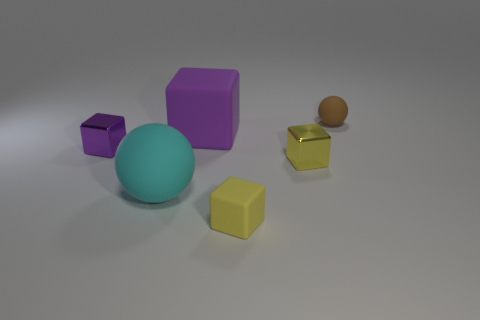There is a big purple object; what shape is it?
Keep it short and to the point. Cube. Does the large matte cube have the same color as the tiny ball?
Your answer should be compact. No. There is a ball that is the same size as the yellow matte cube; what is its color?
Make the answer very short. Brown. How many yellow objects are either tiny matte spheres or spheres?
Give a very brief answer. 0. Are there more brown shiny cylinders than large rubber spheres?
Give a very brief answer. No. Is the size of the metal object behind the small yellow metal cube the same as the thing that is in front of the large cyan object?
Keep it short and to the point. Yes. The matte sphere that is in front of the block behind the tiny object left of the large purple block is what color?
Make the answer very short. Cyan. Is there another big rubber object of the same shape as the cyan object?
Your answer should be very brief. No. Are there more purple rubber cubes that are on the left side of the large cyan rubber thing than metallic things?
Your answer should be very brief. No. What number of matte objects are big objects or yellow cubes?
Your answer should be very brief. 3. 